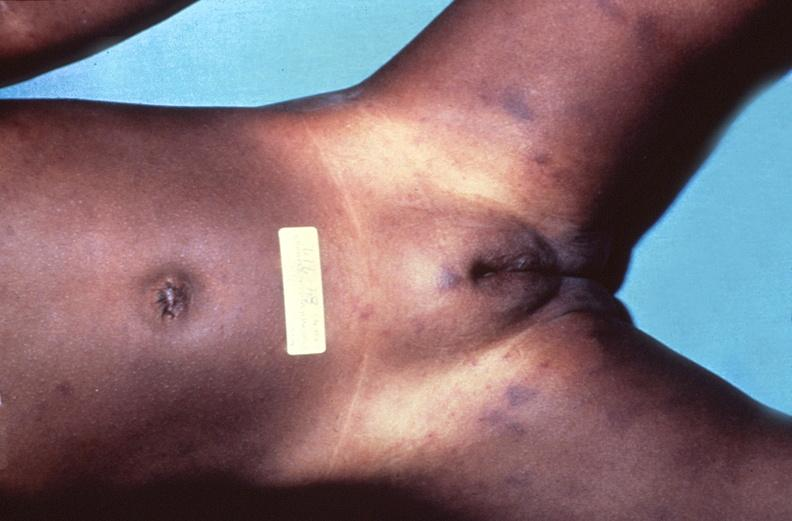where is this?
Answer the question using a single word or phrase. Skin 